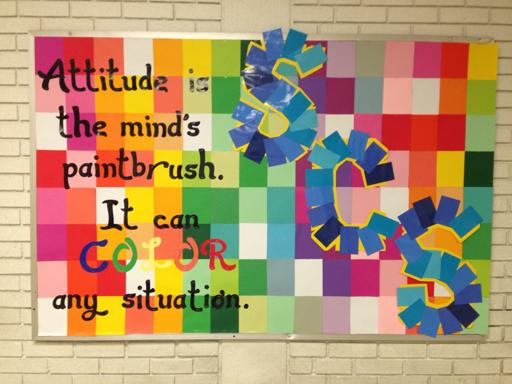How does the use of color in this poster enhance the message of the quote? The use of vivid and diverse colors in the poster enhances the message by visually representing the variety and influence that positive attitudes can have. Each color brings its unique shade to the picture, symbolizing how different positive attitudes can transform and enhance perceptions of various situations, making the overall view more colorful and optimistic. 